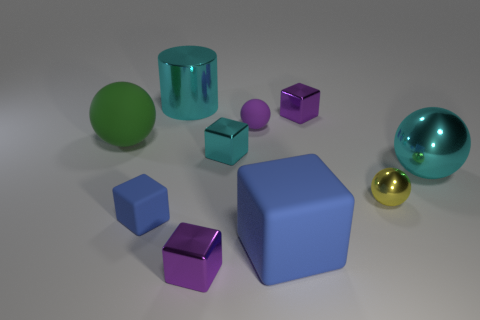Subtract all small cyan metallic blocks. How many blocks are left? 4 Subtract all yellow spheres. How many spheres are left? 3 Subtract 1 cylinders. How many cylinders are left? 0 Subtract all cylinders. How many objects are left? 9 Subtract all brown balls. Subtract all brown blocks. How many balls are left? 4 Subtract all green balls. How many purple blocks are left? 2 Subtract all cyan things. Subtract all large blue cubes. How many objects are left? 6 Add 3 purple matte balls. How many purple matte balls are left? 4 Add 1 tiny cyan shiny cylinders. How many tiny cyan shiny cylinders exist? 1 Subtract 0 blue cylinders. How many objects are left? 10 